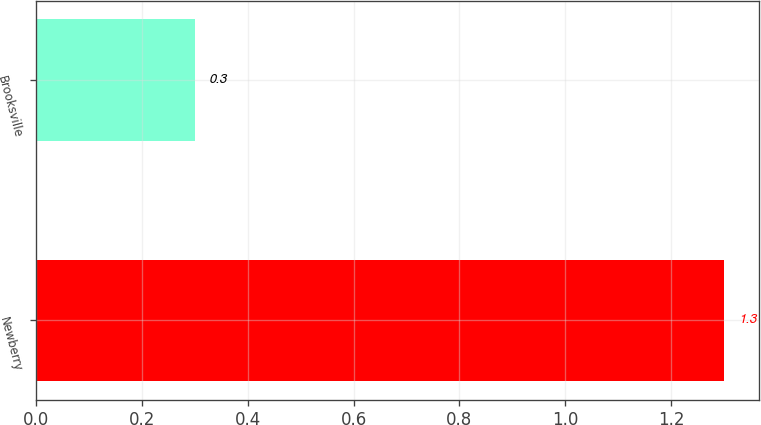Convert chart. <chart><loc_0><loc_0><loc_500><loc_500><bar_chart><fcel>Newberry<fcel>Brooksville<nl><fcel>1.3<fcel>0.3<nl></chart> 